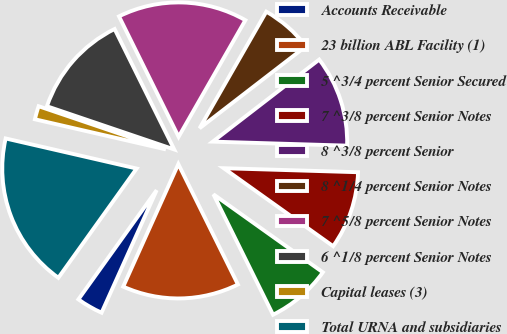Convert chart. <chart><loc_0><loc_0><loc_500><loc_500><pie_chart><fcel>Accounts Receivable<fcel>23 billion ABL Facility (1)<fcel>5 ^3/4 percent Senior Secured<fcel>7 ^3/8 percent Senior Notes<fcel>8 ^3/8 percent Senior<fcel>8 ^1/4 percent Senior Notes<fcel>7 ^5/8 percent Senior Notes<fcel>6 ^1/8 percent Senior Notes<fcel>Capital leases (3)<fcel>Total URNA and subsidiaries<nl><fcel>3.17%<fcel>14.04%<fcel>7.83%<fcel>9.38%<fcel>10.93%<fcel>6.27%<fcel>15.59%<fcel>12.48%<fcel>1.61%<fcel>18.7%<nl></chart> 